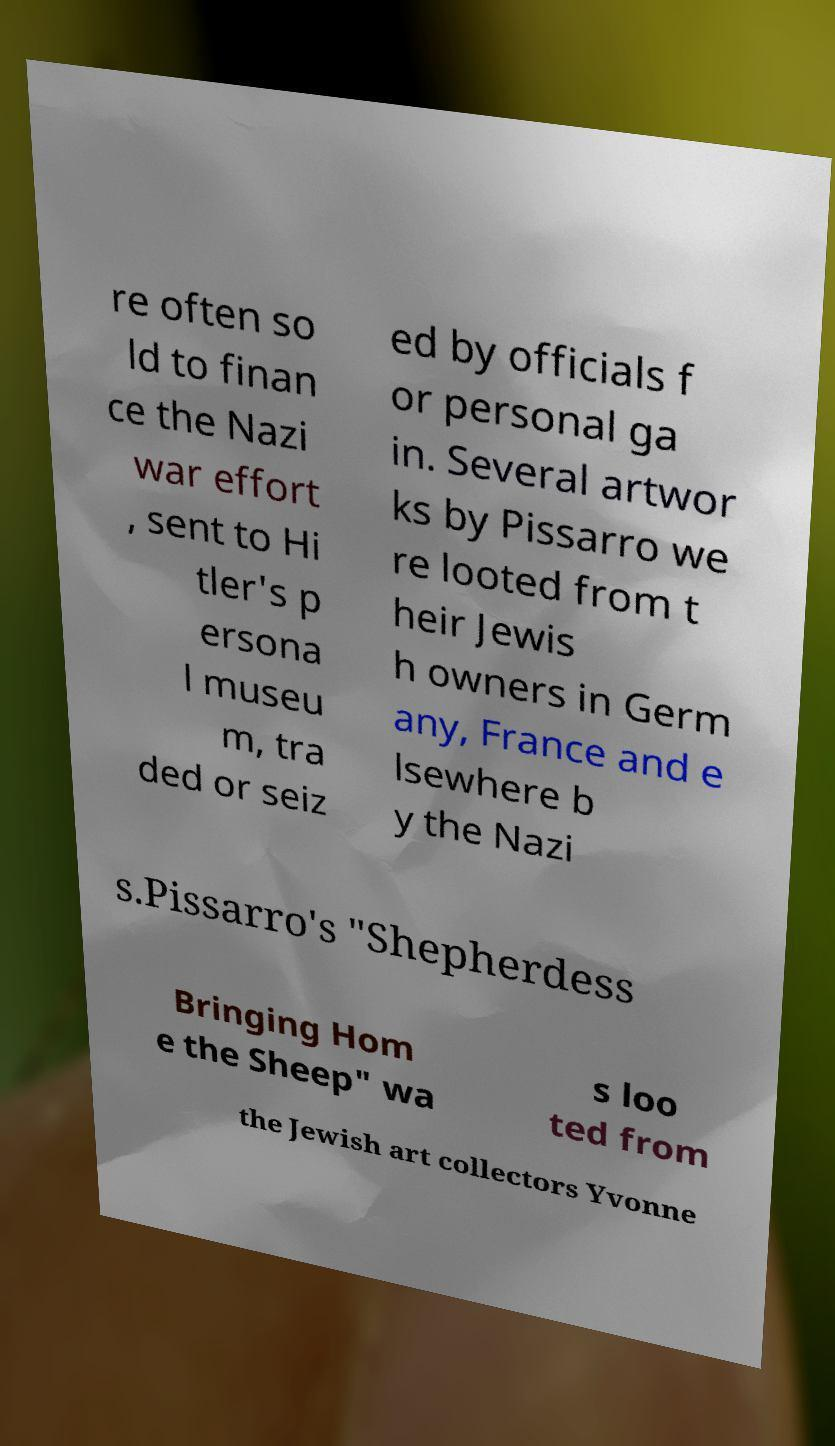For documentation purposes, I need the text within this image transcribed. Could you provide that? re often so ld to finan ce the Nazi war effort , sent to Hi tler's p ersona l museu m, tra ded or seiz ed by officials f or personal ga in. Several artwor ks by Pissarro we re looted from t heir Jewis h owners in Germ any, France and e lsewhere b y the Nazi s.Pissarro's "Shepherdess Bringing Hom e the Sheep" wa s loo ted from the Jewish art collectors Yvonne 